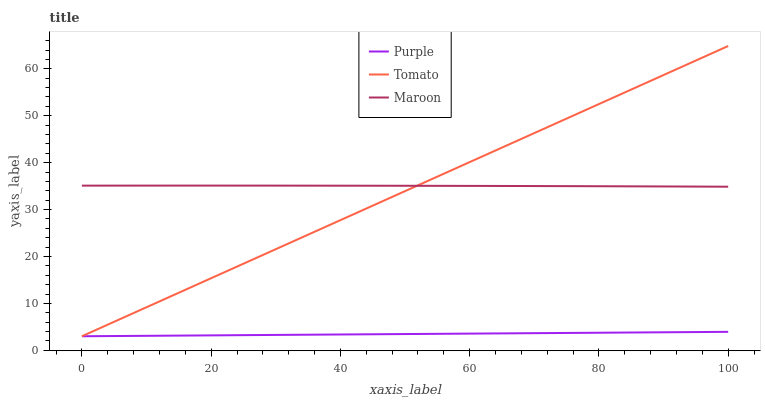Does Purple have the minimum area under the curve?
Answer yes or no. Yes. Does Maroon have the maximum area under the curve?
Answer yes or no. Yes. Does Tomato have the minimum area under the curve?
Answer yes or no. No. Does Tomato have the maximum area under the curve?
Answer yes or no. No. Is Purple the smoothest?
Answer yes or no. Yes. Is Maroon the roughest?
Answer yes or no. Yes. Is Tomato the smoothest?
Answer yes or no. No. Is Tomato the roughest?
Answer yes or no. No. Does Purple have the lowest value?
Answer yes or no. Yes. Does Maroon have the lowest value?
Answer yes or no. No. Does Tomato have the highest value?
Answer yes or no. Yes. Does Maroon have the highest value?
Answer yes or no. No. Is Purple less than Maroon?
Answer yes or no. Yes. Is Maroon greater than Purple?
Answer yes or no. Yes. Does Purple intersect Tomato?
Answer yes or no. Yes. Is Purple less than Tomato?
Answer yes or no. No. Is Purple greater than Tomato?
Answer yes or no. No. Does Purple intersect Maroon?
Answer yes or no. No. 